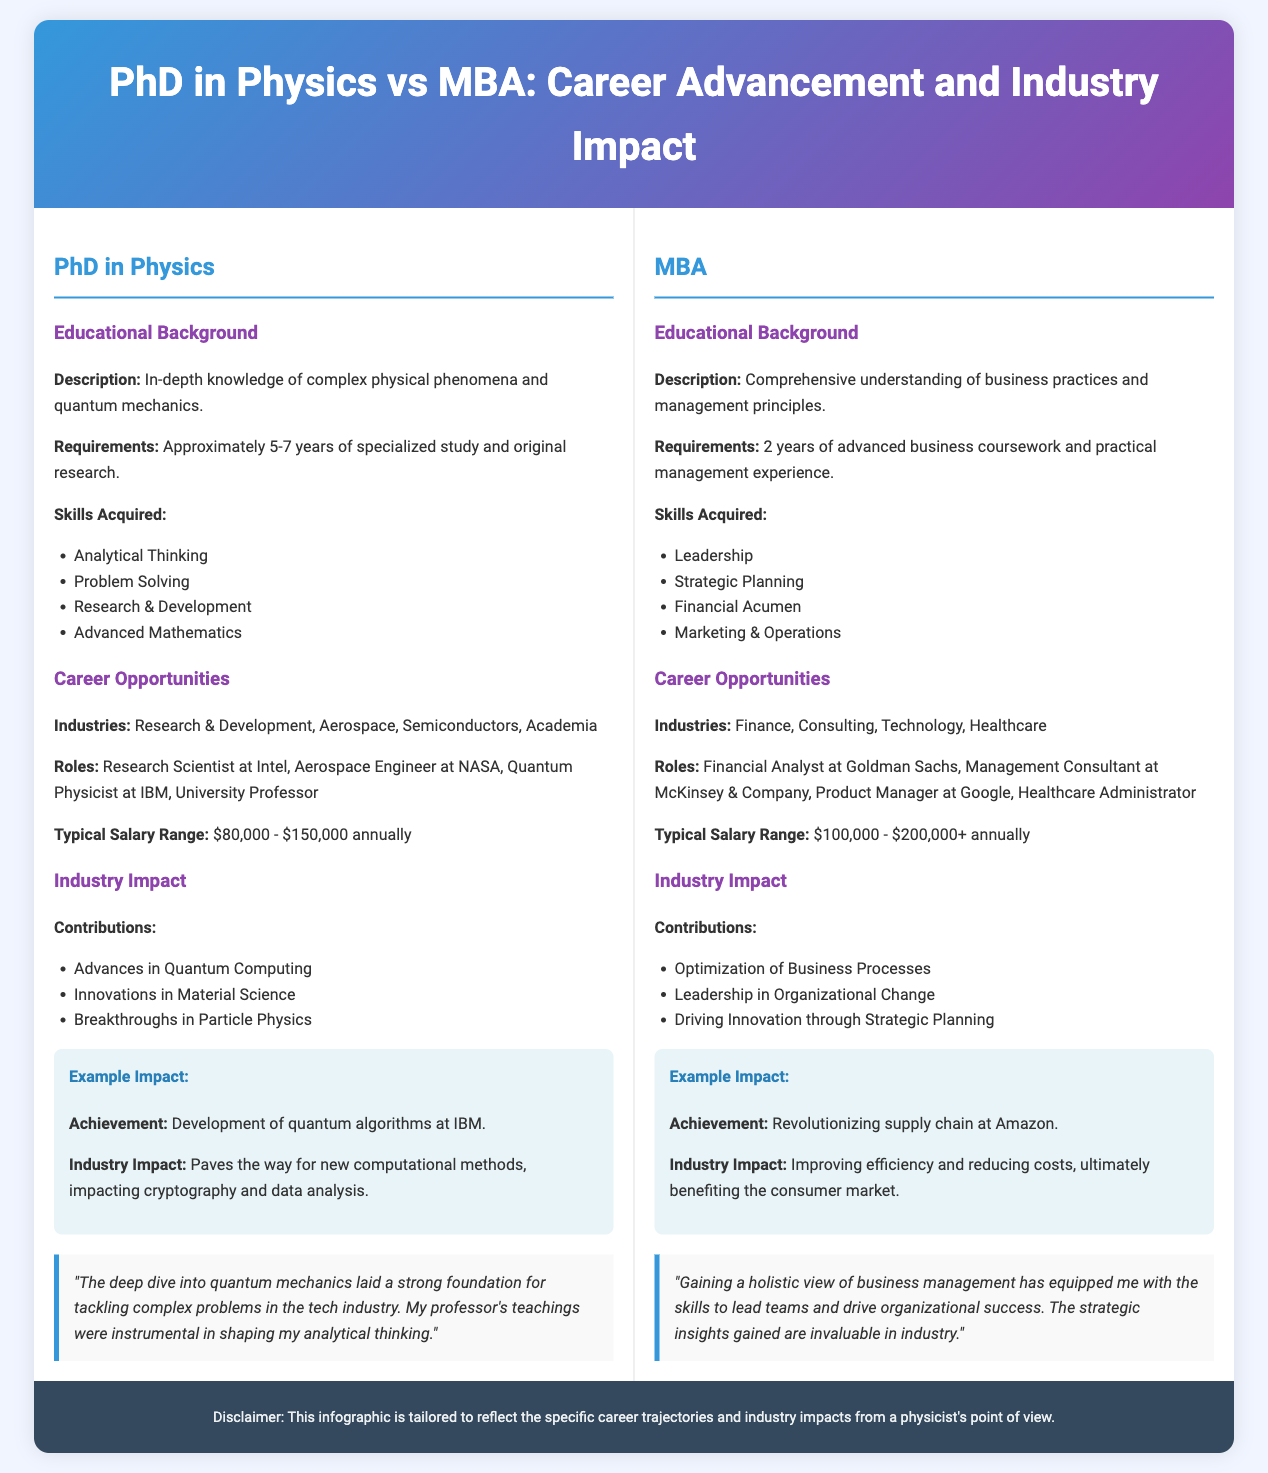What is the typical salary range for a PhD in Physics? The typical salary range for a PhD in Physics is mentioned in the document as $80,000 - $150,000 annually.
Answer: $80,000 - $150,000 annually What industry is NOT listed for MBA career opportunities? The industries listed for MBA career opportunities are Finance, Consulting, Technology, and Healthcare; thus, Aerospace is not included.
Answer: Aerospace How long does it typically take to complete a PhD in Physics? The document states that a PhD in Physics typically requires approximately 5-7 years of specialized study and original research.
Answer: 5-7 years Which role is associated with a PhD in Physics at IBM? The role mentioned for a PhD in Physics at IBM is Quantum Physicist.
Answer: Quantum Physicist What is an example of a contribution from MBA professionals? One example of a contribution from MBA professionals is driving innovation through strategic planning.
Answer: Driving innovation through strategic planning How many years of experience are typically required for an MBA? According to the document, an MBA typically requires 2 years of advanced business coursework and practical management experience.
Answer: 2 years What is a key skill acquired through a PhD in Physics? The document lists analytical thinking as one of the skills acquired through a PhD in Physics.
Answer: Analytical Thinking What is the achievement highlighted for the MBA impact example? The achievement highlighted for the MBA impact example is revolutionizing supply chain at Amazon.
Answer: Revolutionizing supply chain at Amazon 